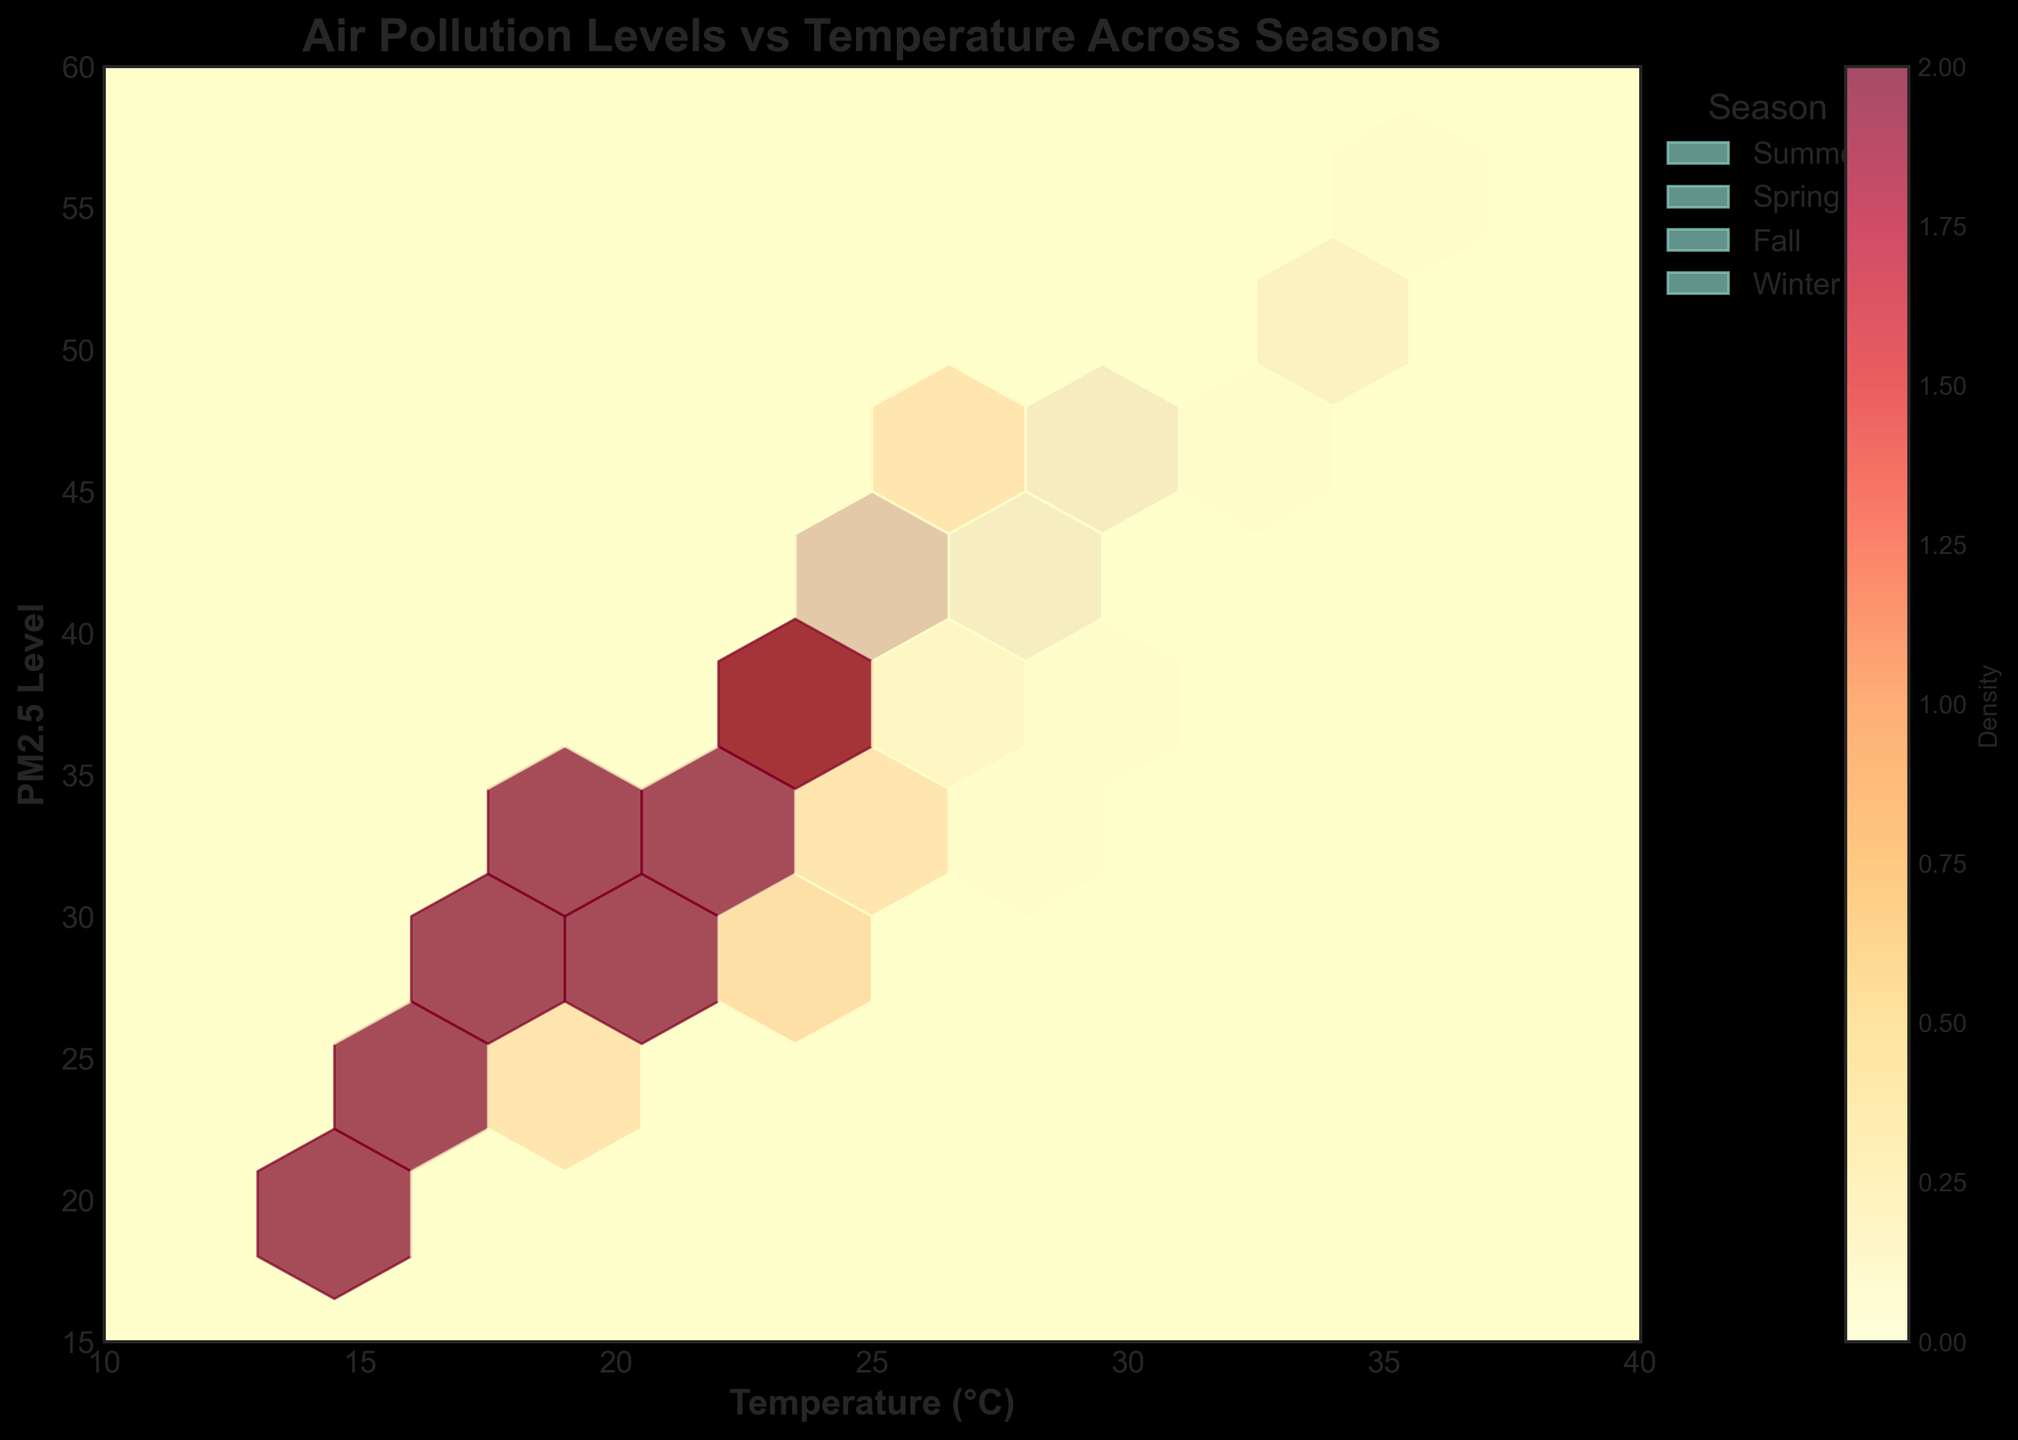What is the title of the plot? The title is displayed at the top of the plot. It reads, "Air Pollution Levels vs Temperature Across Seasons."
Answer: Air Pollution Levels vs Temperature Across Seasons What seasons are represented in the plot? The plot uses a legend that lists the seasons represented in the data. There are four seasons: Summer, Spring, Fall, and Winter.
Answer: Summer, Spring, Fall, Winter What are the labels of the x and y axes? The x-axis is labeled "Temperature (°C)" and the y-axis is labeled "PM2.5 Level." These labels are located along the respective axes.
Answer: Temperature (°C), PM2.5 Level Which season has the highest density of data points for PM2.5 levels between 30 and 50? By examining the color intensity in the hexbin plot, we see that Summer has the highest density of data points for PM2.5 levels between 30 and 50.
Answer: Summer What is the general trend observed in PM2.5 levels as temperature increases across all seasons? The hexbin plot shows a positive trend where PM2.5 levels increase as temperature rises across all seasons, as indicated by the distribution of hexagons.
Answer: PM2.5 levels increase with temperature Which two seasons have the closest density distribution around a temperature of 28°C? By examining the hexbin plot, Fall and Summer show similar density distributions around a temperature of 28°C, indicated by the similarity in the concentration and color density of hexagons.
Answer: Fall and Summer In which temperature range is the density of data points for Winter the highest? The hexbin plot shows the highest density of data points for Winter in the temperature range of 15-23°C, as indicated by the concentration of darker hexagons.
Answer: 15-23°C Is there any temperature range where no PM2.5 levels are recorded for any season? By inspecting the hexbin plot grid visually, there are no empty regions between the x-axis range (10-40°C) and y-axis range (15-60), indicating that all temperature ranges within these limits have recorded PM2.5 levels.
Answer: No How do the PM2.5 levels in Spring compare to those in Summer at high temperatures? At higher temperatures, Summer has higher PM2.5 levels compared to Spring, as indicated by the lighter colors in Spring and darker hexagons in Summer in the upper right part of the plot.
Answer: Higher in Summer Which season appears to have the most widespread range of PM2.5 levels? Spring has the most widespread range of PM2.5 levels, spanning from low to high values, indicated by the distribution of hexagons covering a wide range on the PM2.5 axis.
Answer: Spring 